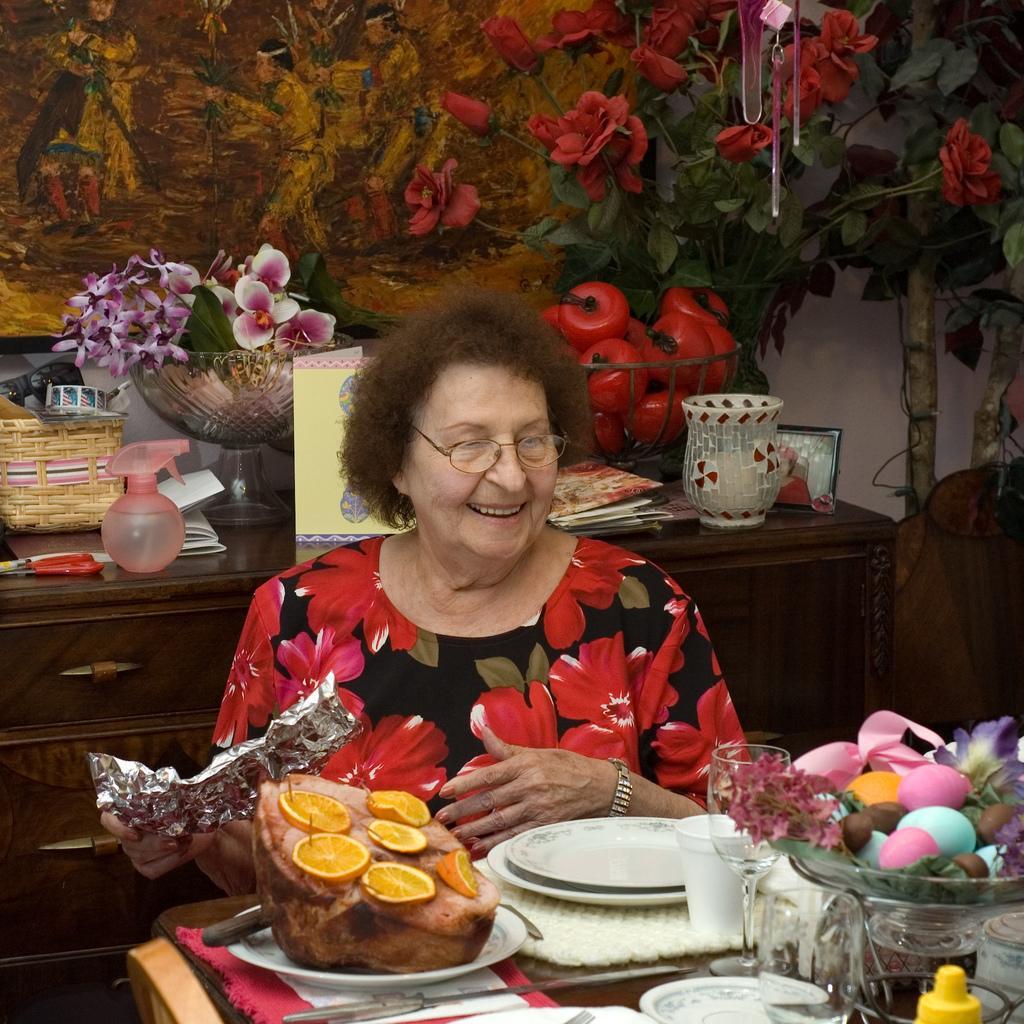How would you summarize this image in a sentence or two? It is a dining room, a woman wearing red and black dress is sitting in front of the table and there are some food items, easter eggs, glasses and plates are placed in front of her on the table , behind her there is a spraying bottle,scissors, bowls some artificial fruits , a jug placed on the cupboard in the background there is artificial tree, and some arts on the wall. 